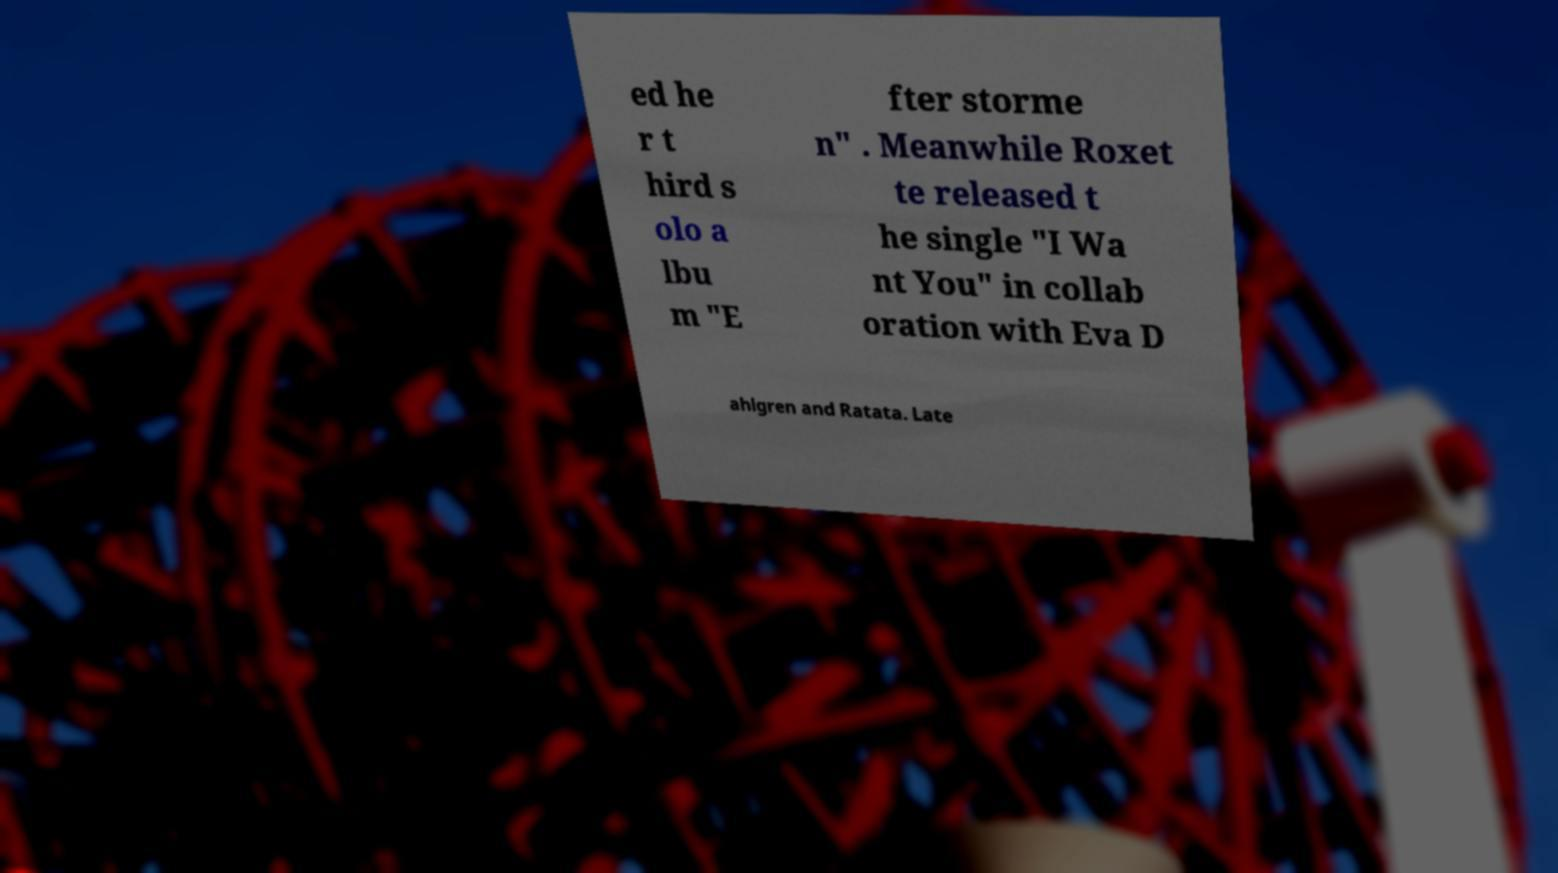Could you extract and type out the text from this image? ed he r t hird s olo a lbu m "E fter storme n" . Meanwhile Roxet te released t he single "I Wa nt You" in collab oration with Eva D ahlgren and Ratata. Late 